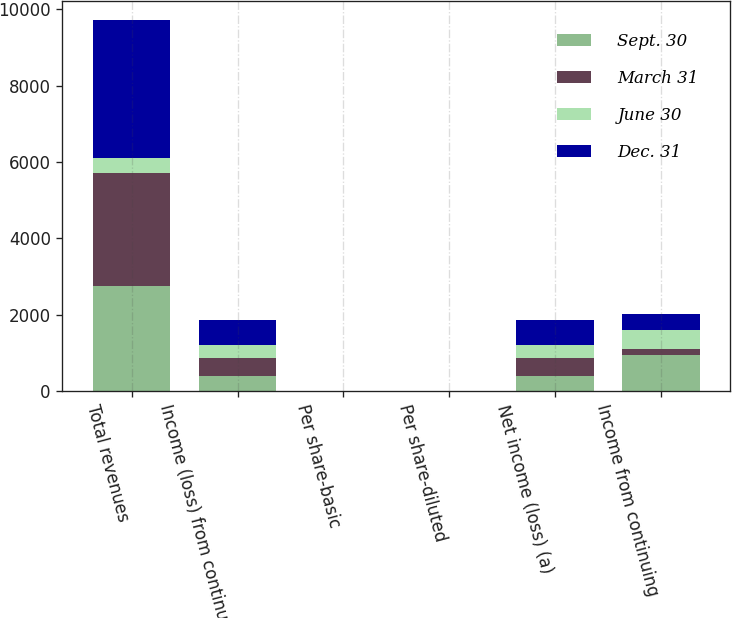Convert chart to OTSL. <chart><loc_0><loc_0><loc_500><loc_500><stacked_bar_chart><ecel><fcel>Total revenues<fcel>Income (loss) from continuing<fcel>Per share-basic<fcel>Per share-diluted<fcel>Net income (loss) (a)<fcel>Income from continuing<nl><fcel>Sept. 30<fcel>2743<fcel>403<fcel>2.2<fcel>0.94<fcel>403<fcel>958<nl><fcel>March 31<fcel>2970<fcel>469<fcel>0.33<fcel>1.08<fcel>468<fcel>144<nl><fcel>June 30<fcel>403<fcel>341<fcel>1<fcel>0.78<fcel>340<fcel>511<nl><fcel>Dec. 31<fcel>3612<fcel>647<fcel>0.77<fcel>1.49<fcel>647<fcel>409<nl></chart> 